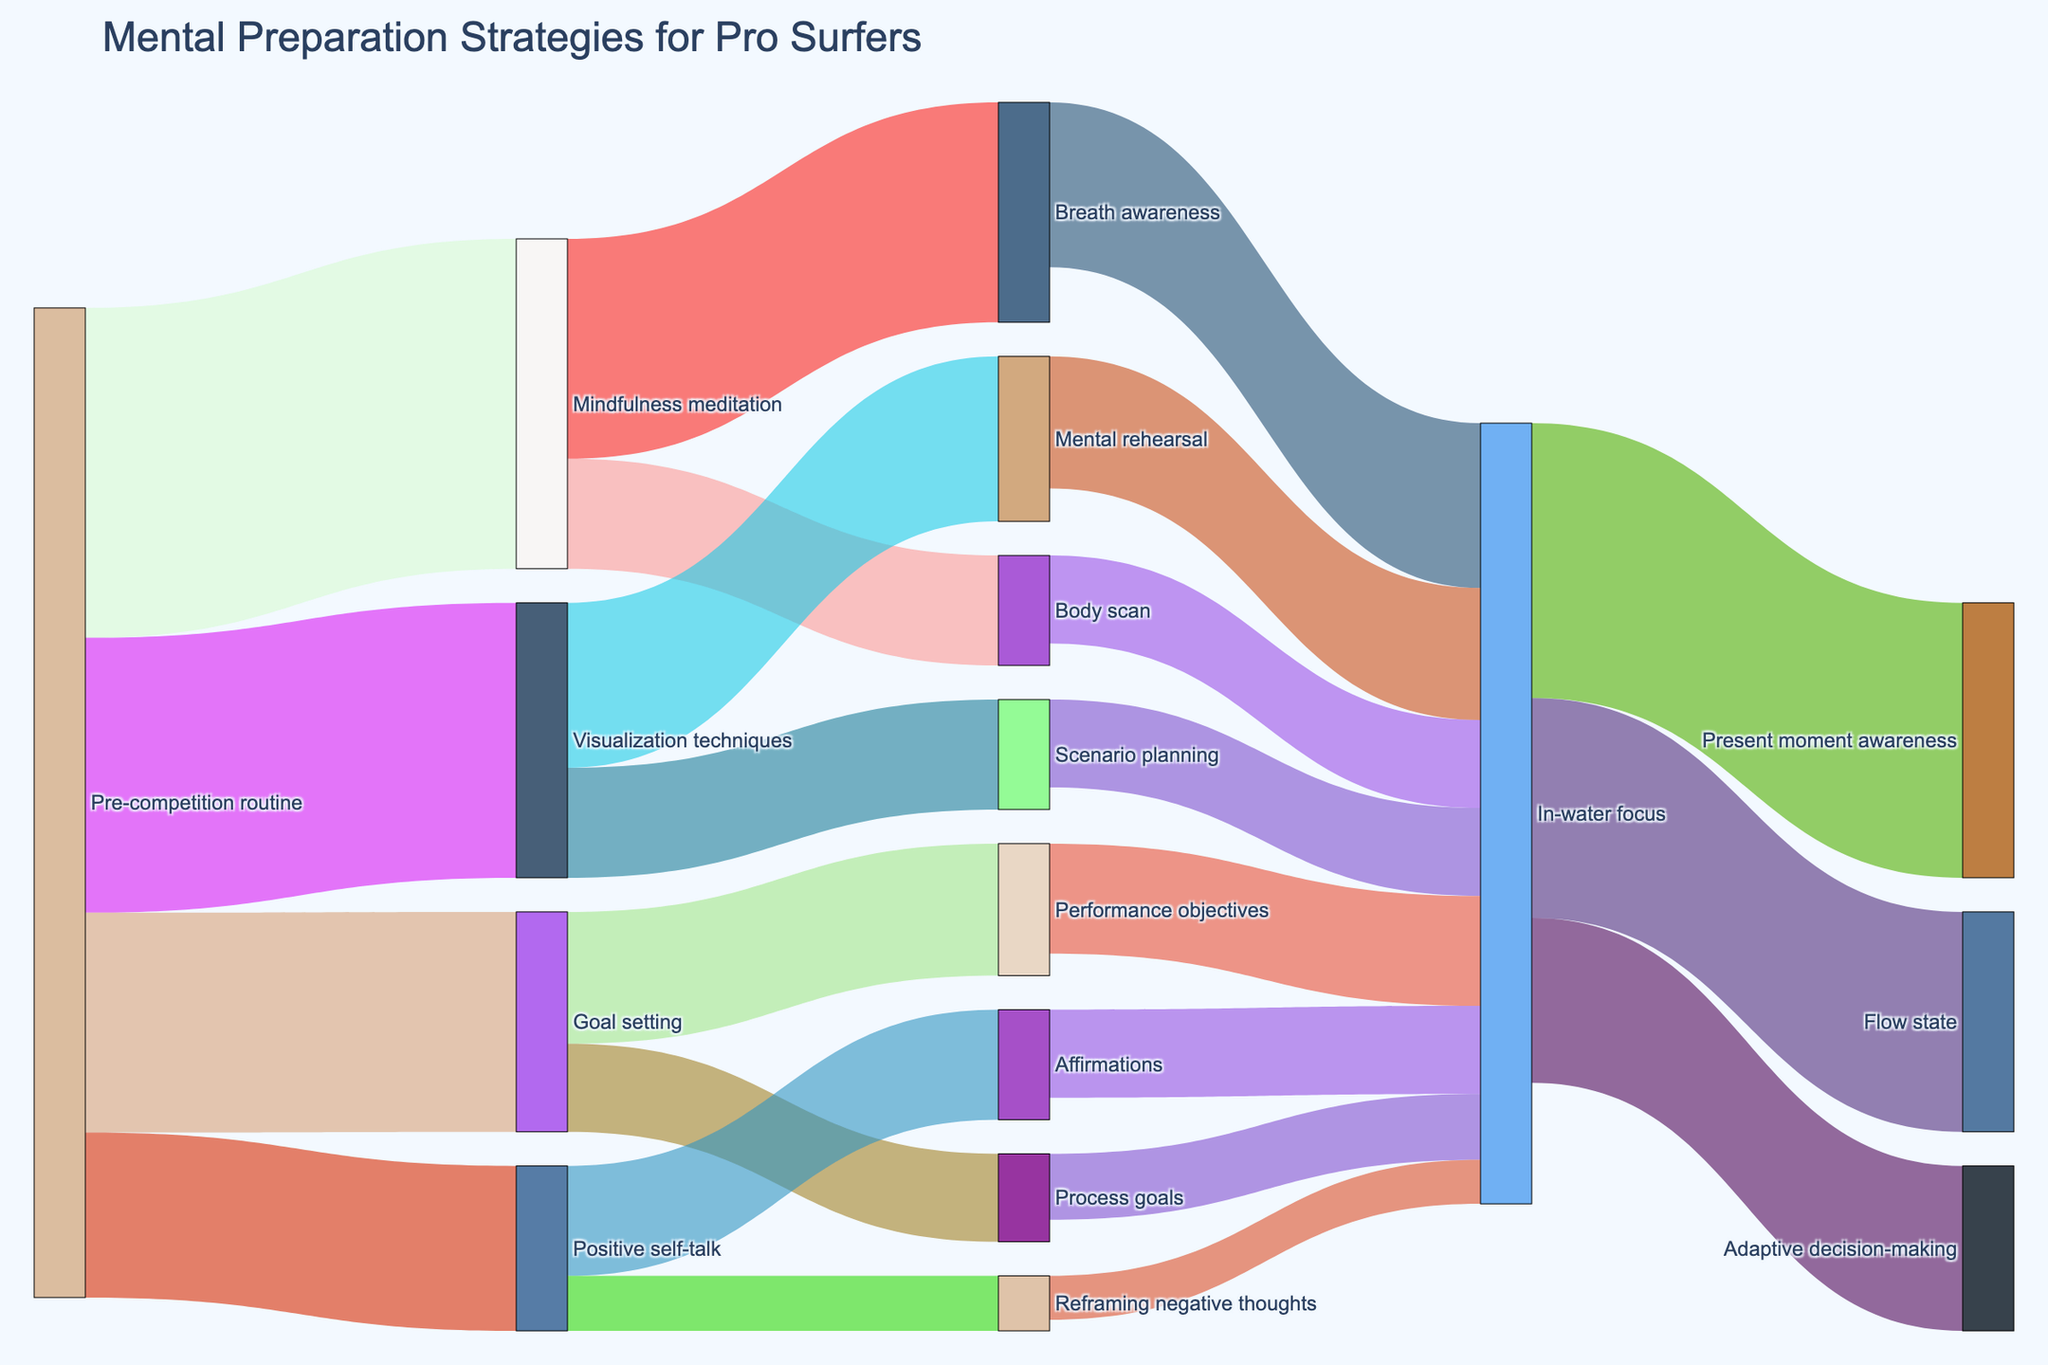What is the title of the figure? The title is usually displayed at the top of the figure, summarizing its content.
Answer: "Mental Preparation Strategies for Pro Surfers" How many main pre-competition routines are shown in the figure? Count the number of unique labels originating from "Pre-competition routine."
Answer: Four Which pre-competition routine has the highest value? Identify the connection from "Pre-competition routine" with the largest number.
Answer: Mindfulness meditation What is the combined value of all activities stemming from "Pre-competition routine"? Sum the values of all activities directly connected to "Pre-competition routine." 30 + 25 + 20 + 15 = 90
Answer: 90 How do "Mindfulness meditation" and "Goal setting" compare in terms of their combined contribution to "In-water focus"? Add the values of activities under both "Mindfulness meditation" and "Goal setting" that lead to "In-water focus" and compare the totals. (20 + 8) vs. (10 + 6) = 28 vs. 18
Answer: Mindfulness meditation is greater Which activity under "Positive self-talk" has a lesser contribution to "In-water focus"? Compare the values of "Affirmations" and "Reframing negative thoughts" that flow into "In-water focus."
Answer: Reframing negative thoughts What are the final targets of the "In-water focus" block? Identify the labels that receive flows from "In-water focus."
Answer: Present moment awareness, Flow state, Adaptive decision-making Which in-water focus technique receives the highest input value? Compare the incoming values to each target of "In-water focus."
Answer: Present moment awareness How does the value of "Performance objectives" compare to "Process goals" in their flow to "In-water focus"? Identify and compare the values contributed to "In-water focus" from "Performance objectives" and "Process goals."
Answer: Performance objectives is greater What's the combined total value reaching "Flow state"? Sum all incoming values to "Flow state."
Answer: 20 